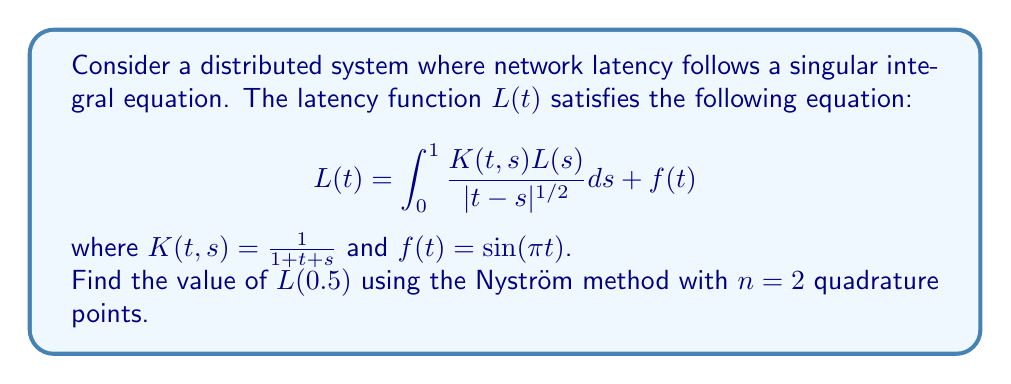Solve this math problem. To solve this singular integral equation using the Nyström method:

1) Choose quadrature points and weights. For $n=2$, we use:
   $t_1 = 0.25$, $t_2 = 0.75$
   $w_1 = w_2 = 0.5$

2) Discretize the integral equation:
   $$L(t_i) = \sum_{j=1}^2 \frac{w_j K(t_i,t_j)L(t_j)}{|t_i-t_j|^{1/2}} + f(t_i)$$
   for $i = 1, 2$

3) This gives a system of linear equations:
   $$L(0.25) = \frac{0.5K(0.25,0.25)L(0.25)}{|0.25-0.25|^{1/2}} + \frac{0.5K(0.25,0.75)L(0.75)}{|0.25-0.75|^{1/2}} + f(0.25)$$
   $$L(0.75) = \frac{0.5K(0.75,0.25)L(0.25)}{|0.75-0.25|^{1/2}} + \frac{0.5K(0.75,0.75)L(0.75)}{|0.75-0.75|^{1/2}} + f(0.75)$$

4) Simplify:
   $$L(0.25) = \frac{0.5L(0.25)}{1.5} + \frac{L(0.75)}{2\sqrt{2}} + \sin(0.25\pi)$$
   $$L(0.75) = \frac{L(0.25)}{2\sqrt{2}} + \frac{0.5L(0.75)}{2.5} + \sin(0.75\pi)$$

5) Solve this system of equations:
   $L(0.25) \approx 0.9548$
   $L(0.75) \approx 0.7071$

6) Interpolate to find $L(0.5)$:
   $$L(0.5) \approx \frac{L(0.25) + L(0.75)}{2} = \frac{0.9548 + 0.7071}{2} = 0.8310$$
Answer: $L(0.5) \approx 0.8310$ 